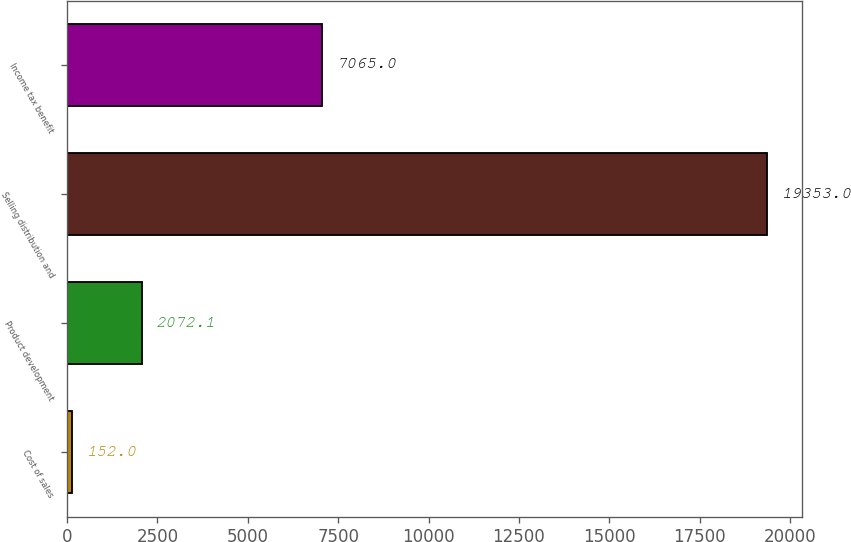Convert chart to OTSL. <chart><loc_0><loc_0><loc_500><loc_500><bar_chart><fcel>Cost of sales<fcel>Product development<fcel>Selling distribution and<fcel>Income tax benefit<nl><fcel>152<fcel>2072.1<fcel>19353<fcel>7065<nl></chart> 